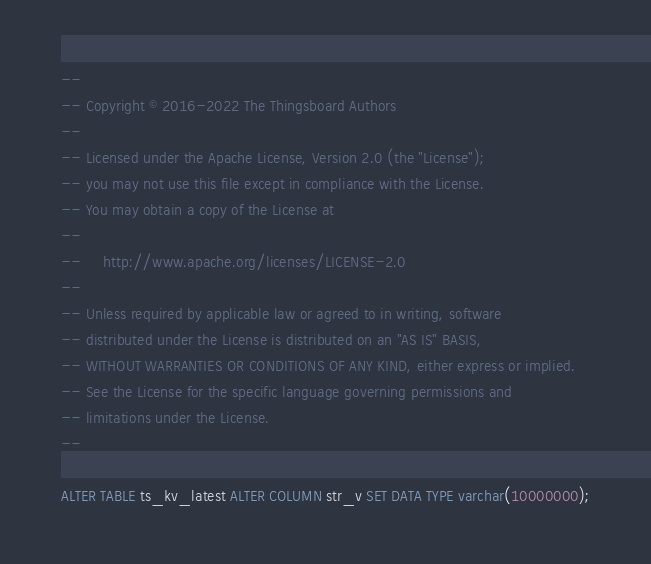Convert code to text. <code><loc_0><loc_0><loc_500><loc_500><_SQL_>--
-- Copyright © 2016-2022 The Thingsboard Authors
--
-- Licensed under the Apache License, Version 2.0 (the "License");
-- you may not use this file except in compliance with the License.
-- You may obtain a copy of the License at
--
--     http://www.apache.org/licenses/LICENSE-2.0
--
-- Unless required by applicable law or agreed to in writing, software
-- distributed under the License is distributed on an "AS IS" BASIS,
-- WITHOUT WARRANTIES OR CONDITIONS OF ANY KIND, either express or implied.
-- See the License for the specific language governing permissions and
-- limitations under the License.
--

ALTER TABLE ts_kv_latest ALTER COLUMN str_v SET DATA TYPE varchar(10000000);
</code> 